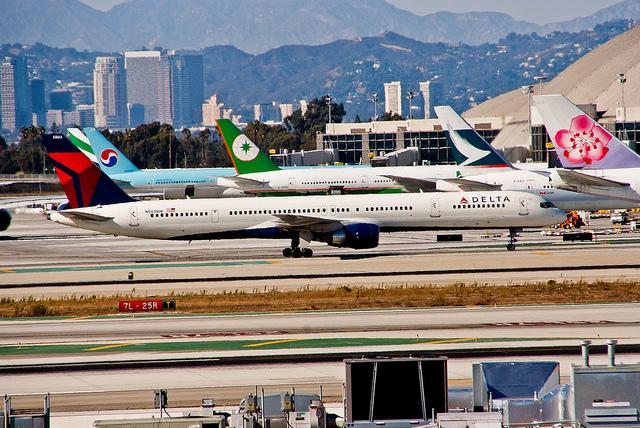What airlines are represented in the picture?
Quick response, please. Delta. What airport is this plane at?
Short answer required. Delta. Are there mountains in the background?
Concise answer only. Yes. Is the plane getting ready to take off?
Answer briefly. Yes. 